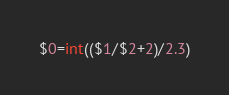<code> <loc_0><loc_0><loc_500><loc_500><_Awk_>$0=int(($1/$2+2)/2.3)</code> 